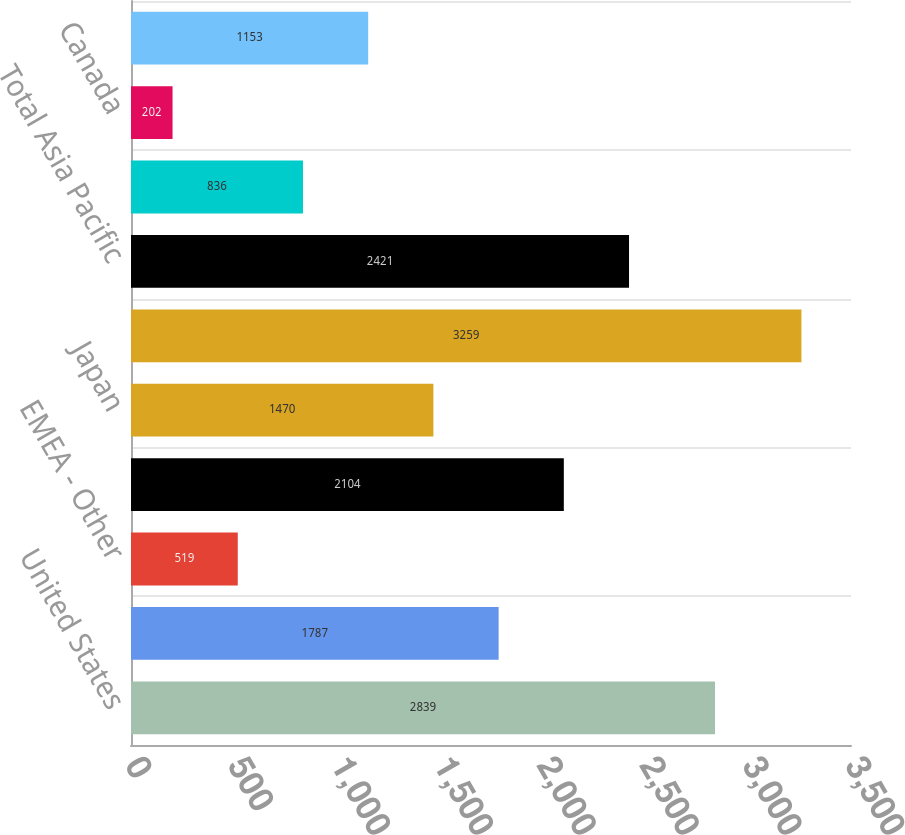Convert chart. <chart><loc_0><loc_0><loc_500><loc_500><bar_chart><fcel>United States<fcel>Europe (b)<fcel>EMEA - Other<fcel>Total EMEA<fcel>Japan<fcel>Asia Pacific - Other<fcel>Total Asia Pacific<fcel>Latin America<fcel>Canada<fcel>Total International Retail<nl><fcel>2839<fcel>1787<fcel>519<fcel>2104<fcel>1470<fcel>3259<fcel>2421<fcel>836<fcel>202<fcel>1153<nl></chart> 